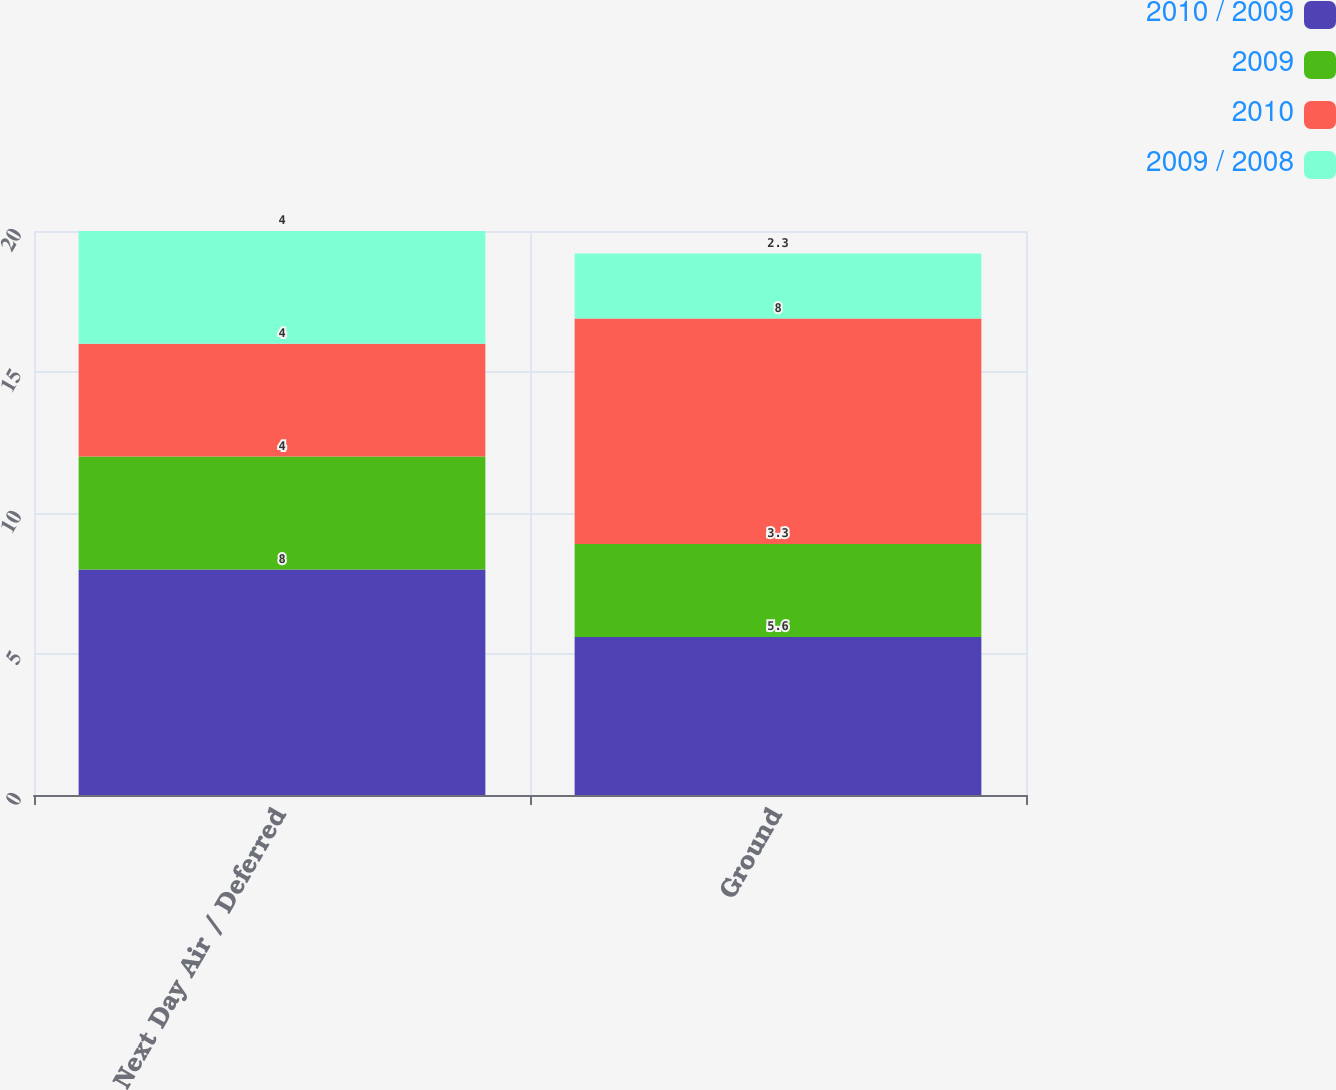<chart> <loc_0><loc_0><loc_500><loc_500><stacked_bar_chart><ecel><fcel>Next Day Air / Deferred<fcel>Ground<nl><fcel>2010 / 2009<fcel>8<fcel>5.6<nl><fcel>2009<fcel>4<fcel>3.3<nl><fcel>2010<fcel>4<fcel>8<nl><fcel>2009 / 2008<fcel>4<fcel>2.3<nl></chart> 